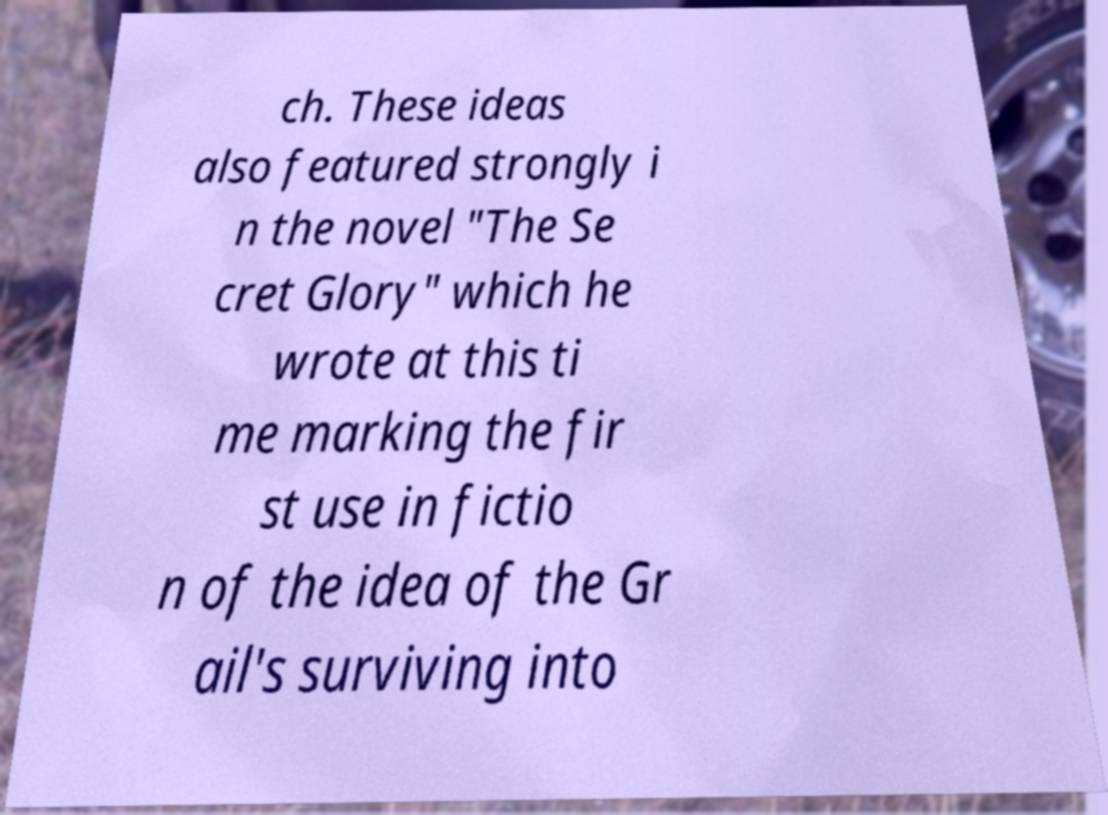Could you assist in decoding the text presented in this image and type it out clearly? ch. These ideas also featured strongly i n the novel "The Se cret Glory" which he wrote at this ti me marking the fir st use in fictio n of the idea of the Gr ail's surviving into 